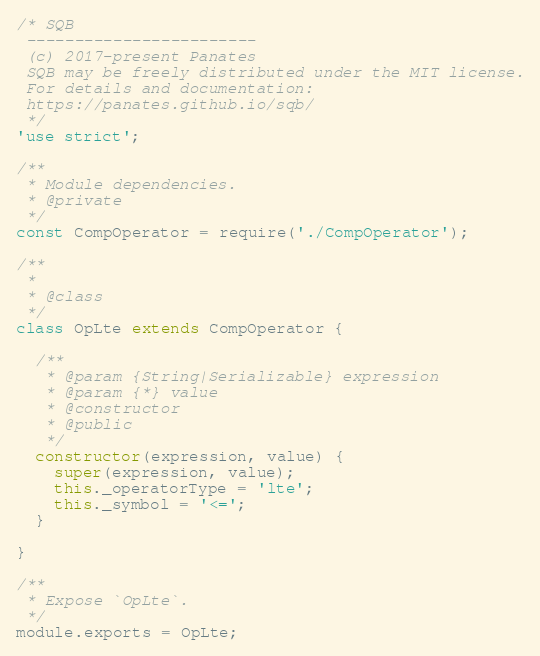Convert code to text. <code><loc_0><loc_0><loc_500><loc_500><_JavaScript_>/* SQB
 ------------------------
 (c) 2017-present Panates
 SQB may be freely distributed under the MIT license.
 For details and documentation:
 https://panates.github.io/sqb/
 */
'use strict';

/**
 * Module dependencies.
 * @private
 */
const CompOperator = require('./CompOperator');

/**
 *
 * @class
 */
class OpLte extends CompOperator {

  /**
   * @param {String|Serializable} expression
   * @param {*} value
   * @constructor
   * @public
   */
  constructor(expression, value) {
    super(expression, value);
    this._operatorType = 'lte';
    this._symbol = '<=';
  }

}

/**
 * Expose `OpLte`.
 */
module.exports = OpLte;
</code> 